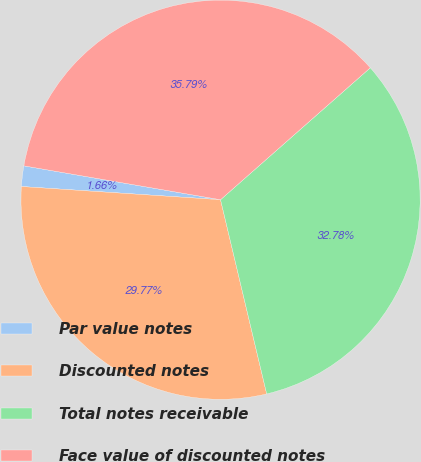Convert chart. <chart><loc_0><loc_0><loc_500><loc_500><pie_chart><fcel>Par value notes<fcel>Discounted notes<fcel>Total notes receivable<fcel>Face value of discounted notes<nl><fcel>1.66%<fcel>29.77%<fcel>32.78%<fcel>35.79%<nl></chart> 